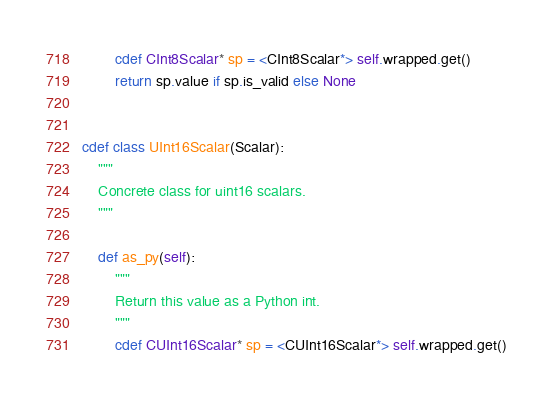Convert code to text. <code><loc_0><loc_0><loc_500><loc_500><_Cython_>        cdef CInt8Scalar* sp = <CInt8Scalar*> self.wrapped.get()
        return sp.value if sp.is_valid else None


cdef class UInt16Scalar(Scalar):
    """
    Concrete class for uint16 scalars.
    """

    def as_py(self):
        """
        Return this value as a Python int.
        """
        cdef CUInt16Scalar* sp = <CUInt16Scalar*> self.wrapped.get()</code> 